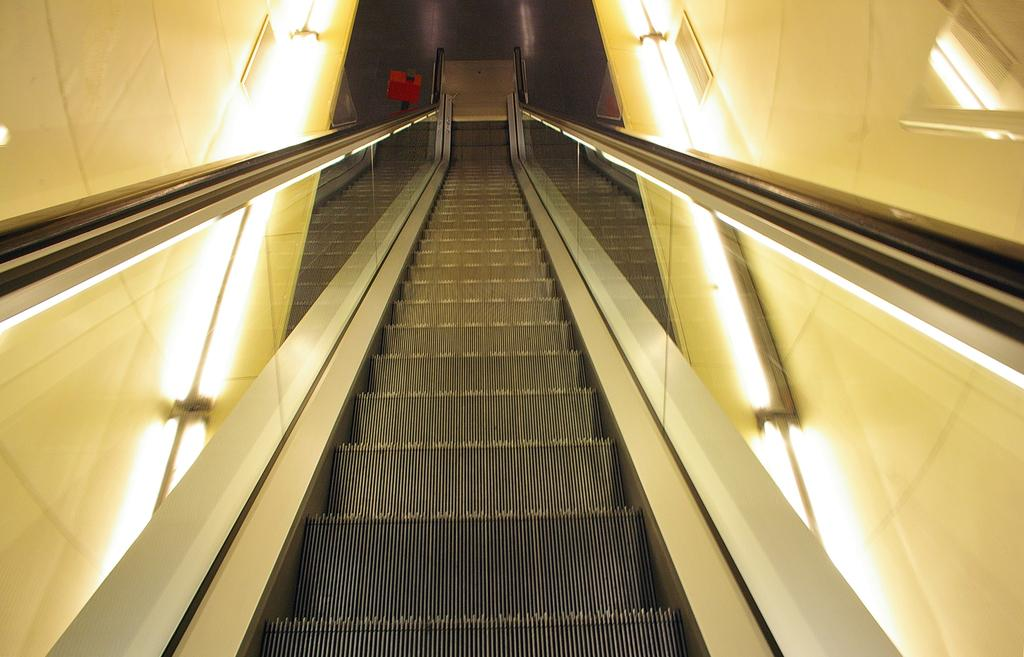What is the main feature in the center of the image? There are stairs in the center of the image. Are there any additional features near the stairs? Yes, there are lights on both sides of the stairs. What can be seen at the top of the image? There is a red color thing at the top of the image. Can you see any quivering snakes with teeth in the image? No, there are no snakes or quivering objects present in the image. 